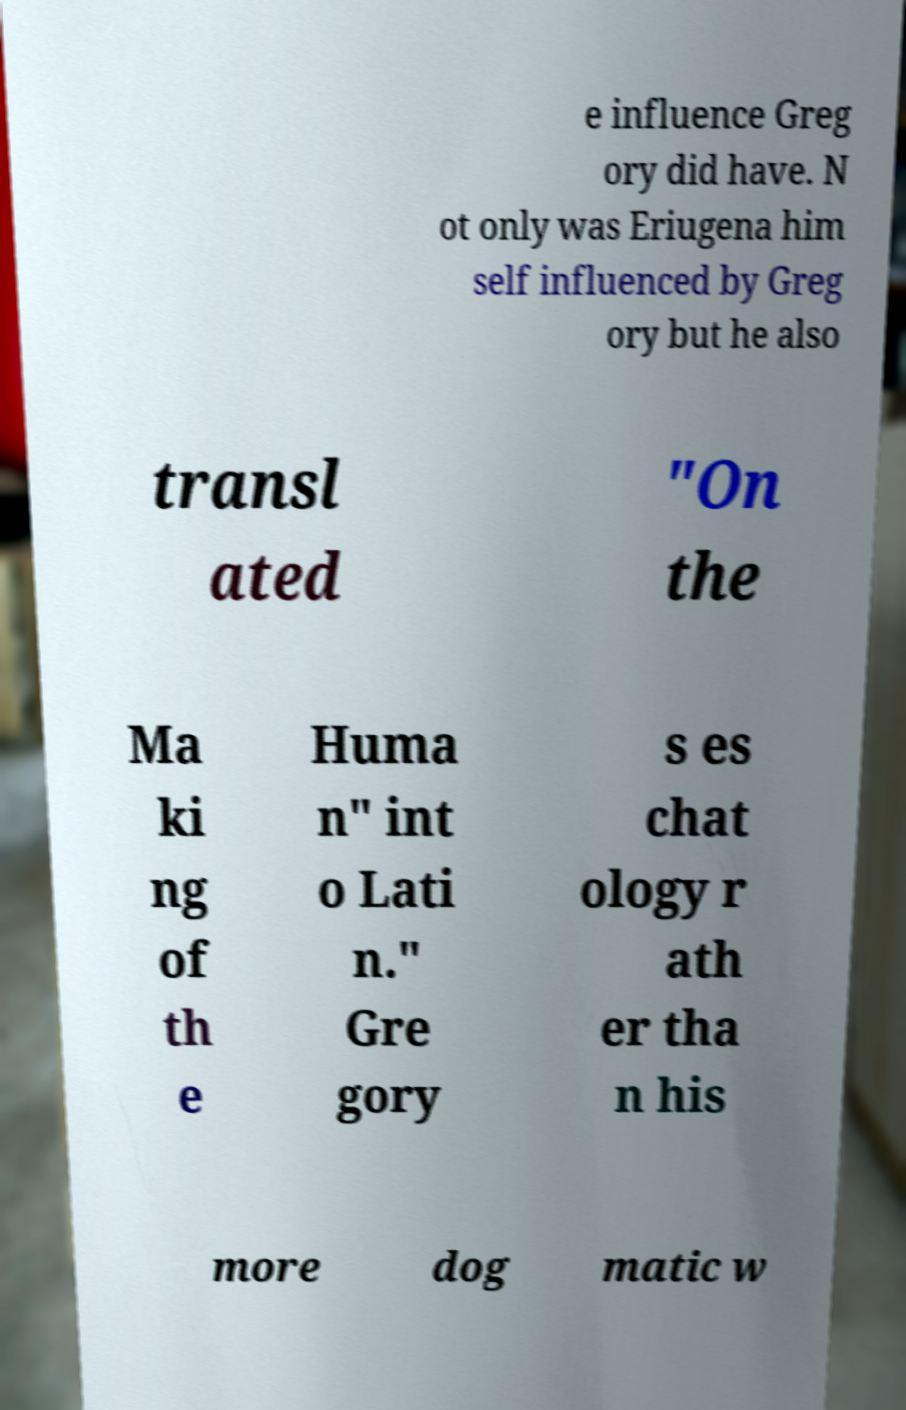Could you extract and type out the text from this image? e influence Greg ory did have. N ot only was Eriugena him self influenced by Greg ory but he also transl ated "On the Ma ki ng of th e Huma n" int o Lati n." Gre gory s es chat ology r ath er tha n his more dog matic w 